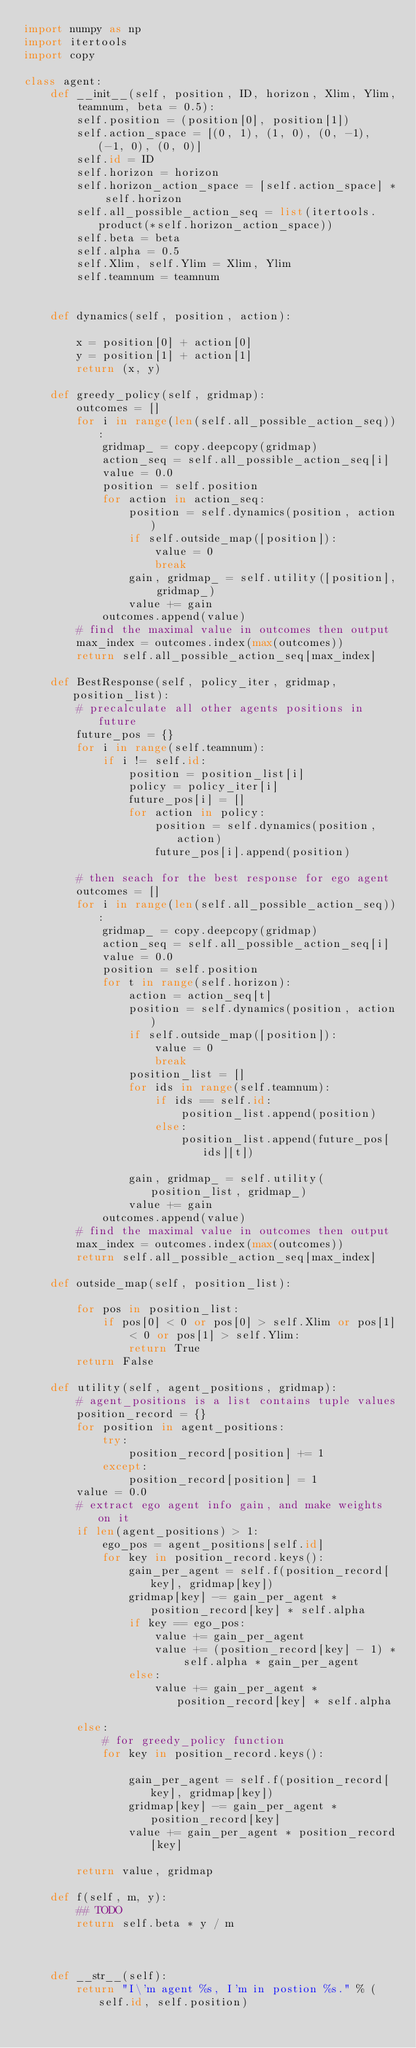<code> <loc_0><loc_0><loc_500><loc_500><_Python_>import numpy as np
import itertools
import copy

class agent:
    def __init__(self, position, ID, horizon, Xlim, Ylim, teamnum, beta = 0.5):
        self.position = (position[0], position[1])
        self.action_space = [(0, 1), (1, 0), (0, -1), (-1, 0), (0, 0)]
        self.id = ID
        self.horizon = horizon        
        self.horizon_action_space = [self.action_space] * self.horizon
        self.all_possible_action_seq = list(itertools.product(*self.horizon_action_space))
        self.beta = beta
        self.alpha = 0.5
        self.Xlim, self.Ylim = Xlim, Ylim
        self.teamnum = teamnum
        
    
    def dynamics(self, position, action):
        
        x = position[0] + action[0]
        y = position[1] + action[1]
        return (x, y)
    
    def greedy_policy(self, gridmap):
        outcomes = []
        for i in range(len(self.all_possible_action_seq)):
            gridmap_ = copy.deepcopy(gridmap)
            action_seq = self.all_possible_action_seq[i]
            value = 0.0
            position = self.position
            for action in action_seq:
                position = self.dynamics(position, action)
                if self.outside_map([position]):
                    value = 0
                    break
                gain, gridmap_ = self.utility([position], gridmap_)
                value += gain
            outcomes.append(value)
        # find the maximal value in outcomes then output
        max_index = outcomes.index(max(outcomes))
        return self.all_possible_action_seq[max_index]
    
    def BestResponse(self, policy_iter, gridmap, position_list):
        # precalculate all other agents positions in future
        future_pos = {}
        for i in range(self.teamnum):
            if i != self.id:
                position = position_list[i]
                policy = policy_iter[i]
                future_pos[i] = []
                for action in policy:
                    position = self.dynamics(position, action)
                    future_pos[i].append(position)

        # then seach for the best response for ego agent
        outcomes = []
        for i in range(len(self.all_possible_action_seq)):
            gridmap_ = copy.deepcopy(gridmap)
            action_seq = self.all_possible_action_seq[i]
            value = 0.0
            position = self.position
            for t in range(self.horizon):
                action = action_seq[t]
                position = self.dynamics(position, action)
                if self.outside_map([position]):
                    value = 0
                    break
                position_list = []
                for ids in range(self.teamnum):
                    if ids == self.id:
                        position_list.append(position)
                    else:
                        position_list.append(future_pos[ids][t])

                gain, gridmap_ = self.utility(position_list, gridmap_)
                value += gain
            outcomes.append(value)
        # find the maximal value in outcomes then output
        max_index = outcomes.index(max(outcomes))
        return self.all_possible_action_seq[max_index]
    
    def outside_map(self, position_list):

        for pos in position_list:
            if pos[0] < 0 or pos[0] > self.Xlim or pos[1] < 0 or pos[1] > self.Ylim:
                return True
        return False

    def utility(self, agent_positions, gridmap):
        # agent_positions is a list contains tuple values
        position_record = {}
        for position in agent_positions:
            try:
                position_record[position] += 1
            except:
                position_record[position] = 1
        value = 0.0
        # extract ego agent info gain, and make weights on it
        if len(agent_positions) > 1:
            ego_pos = agent_positions[self.id]
            for key in position_record.keys():
                gain_per_agent = self.f(position_record[key], gridmap[key])
                gridmap[key] -= gain_per_agent * position_record[key] * self.alpha
                if key == ego_pos:
                    value += gain_per_agent
                    value += (position_record[key] - 1) * self.alpha * gain_per_agent
                else:
                    value += gain_per_agent * position_record[key] * self.alpha
                
        else:
            # for greedy_policy function
            for key in position_record.keys():
                
                gain_per_agent = self.f(position_record[key], gridmap[key])
                gridmap[key] -= gain_per_agent * position_record[key]
                value += gain_per_agent * position_record[key]
        
        return value, gridmap
    
    def f(self, m, y):
        ## TODO
        return self.beta * y / m

        
    
    def __str__(self):
        return "I\'m agent %s, I'm in postion %s." % (self.id, self.position)</code> 